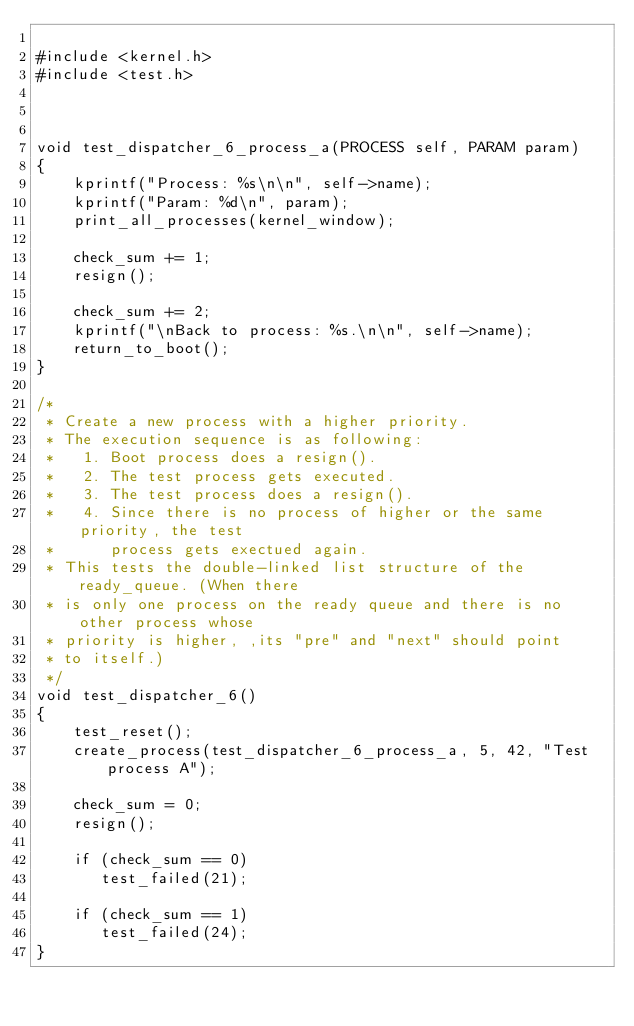Convert code to text. <code><loc_0><loc_0><loc_500><loc_500><_C_>
#include <kernel.h>
#include <test.h>



void test_dispatcher_6_process_a(PROCESS self, PARAM param)
{
    kprintf("Process: %s\n\n", self->name);
    kprintf("Param: %d\n", param);
    print_all_processes(kernel_window);

    check_sum += 1; 
    resign();

    check_sum += 2;
    kprintf("\nBack to process: %s.\n\n", self->name);
    return_to_boot();
}

/*
 * Create a new process with a higher priority.
 * The execution sequence is as following:
 *   1. Boot process does a resign().
 *   2. The test process gets executed.
 *   3. The test process does a resign().
 *   4. Since there is no process of higher or the same priority, the test
 *      process gets exectued again. 
 * This tests the double-linked list structure of the ready_queue. (When there  
 * is only one process on the ready queue and there is no other process whose
 * priority is higher, ,its "pre" and "next" should point
 * to itself.)
 */
void test_dispatcher_6()
{
    test_reset();
    create_process(test_dispatcher_6_process_a, 5, 42, "Test process A");

    check_sum = 0;
    resign();

    if (check_sum == 0)
       test_failed(21);

    if (check_sum == 1)
       test_failed(24);
}

</code> 